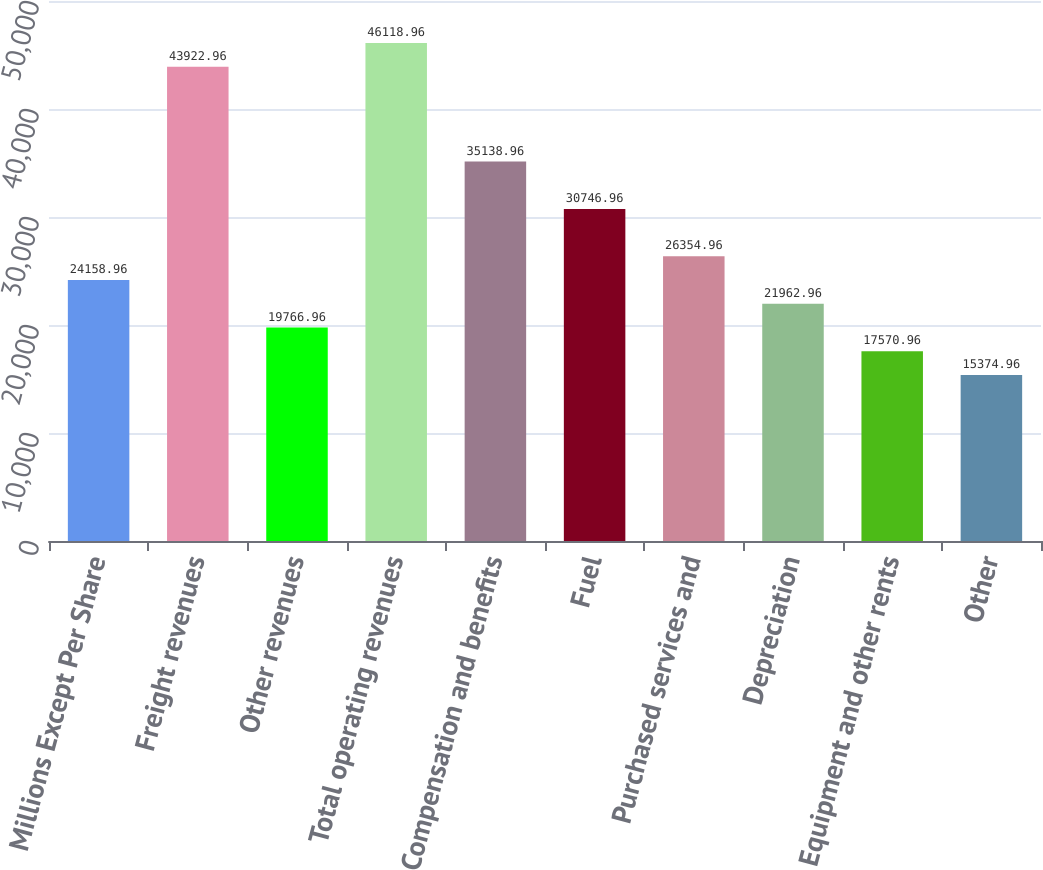Convert chart to OTSL. <chart><loc_0><loc_0><loc_500><loc_500><bar_chart><fcel>Millions Except Per Share<fcel>Freight revenues<fcel>Other revenues<fcel>Total operating revenues<fcel>Compensation and benefits<fcel>Fuel<fcel>Purchased services and<fcel>Depreciation<fcel>Equipment and other rents<fcel>Other<nl><fcel>24159<fcel>43923<fcel>19767<fcel>46119<fcel>35139<fcel>30747<fcel>26355<fcel>21963<fcel>17571<fcel>15375<nl></chart> 